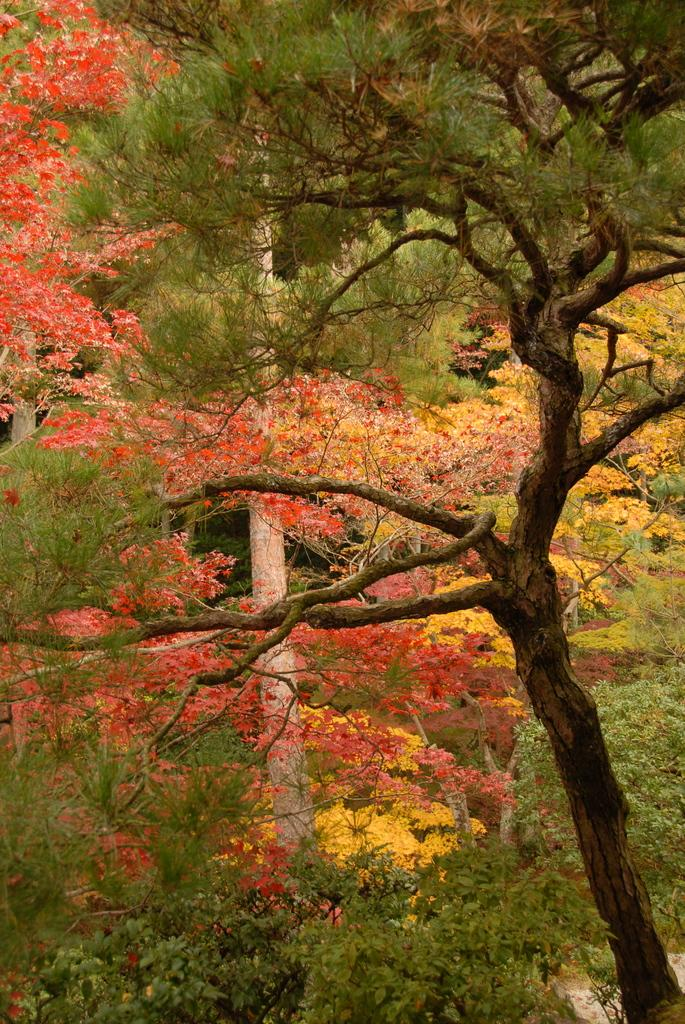What type of vegetation can be seen in the image? There are trees in the image. What colors are the flowers in the image? The flowers in the image are red and yellow. What type of locket is hanging from the tree in the image? There is no locket present in the image; it only features trees and flowers. How many cattle can be seen grazing in the image? There are no cattle present in the image. 